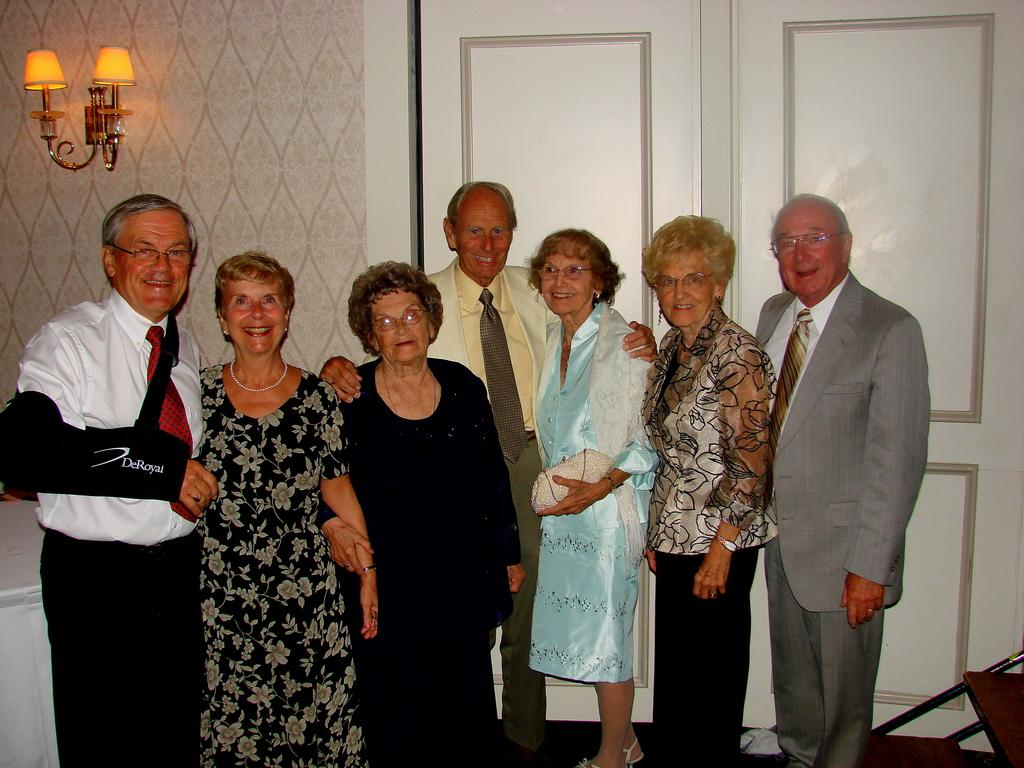How many people are in the image? There are people in the image. What is the background of the image? There is a wall in the image. Is there any entrance or exit in the image? Yes, there is a door in the image. What else can be seen in the image besides people and the wall? There are objects in the image. Are there any light sources visible in the image? Yes, lights are present on the wall. What might one person be carrying in the image? One person is holding a purse. What type of bun is being served at the statement in the image? There is no statement or bun present in the image. 